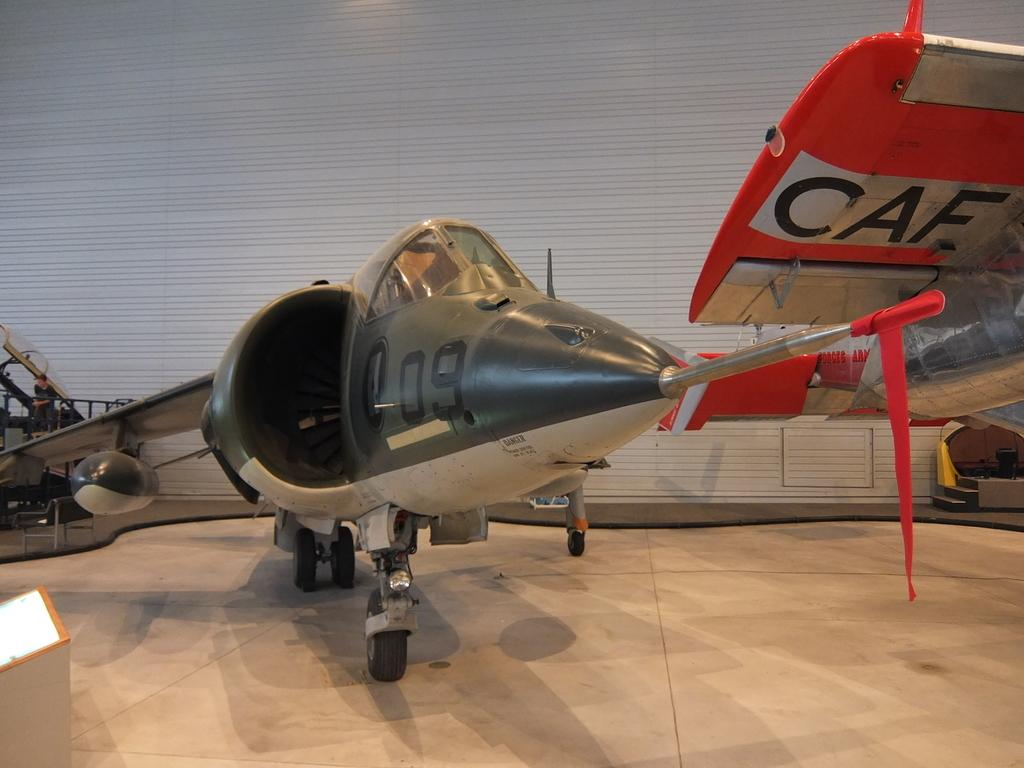<image>
Share a concise interpretation of the image provided. A model airplane with the numbers 09 written on the front 